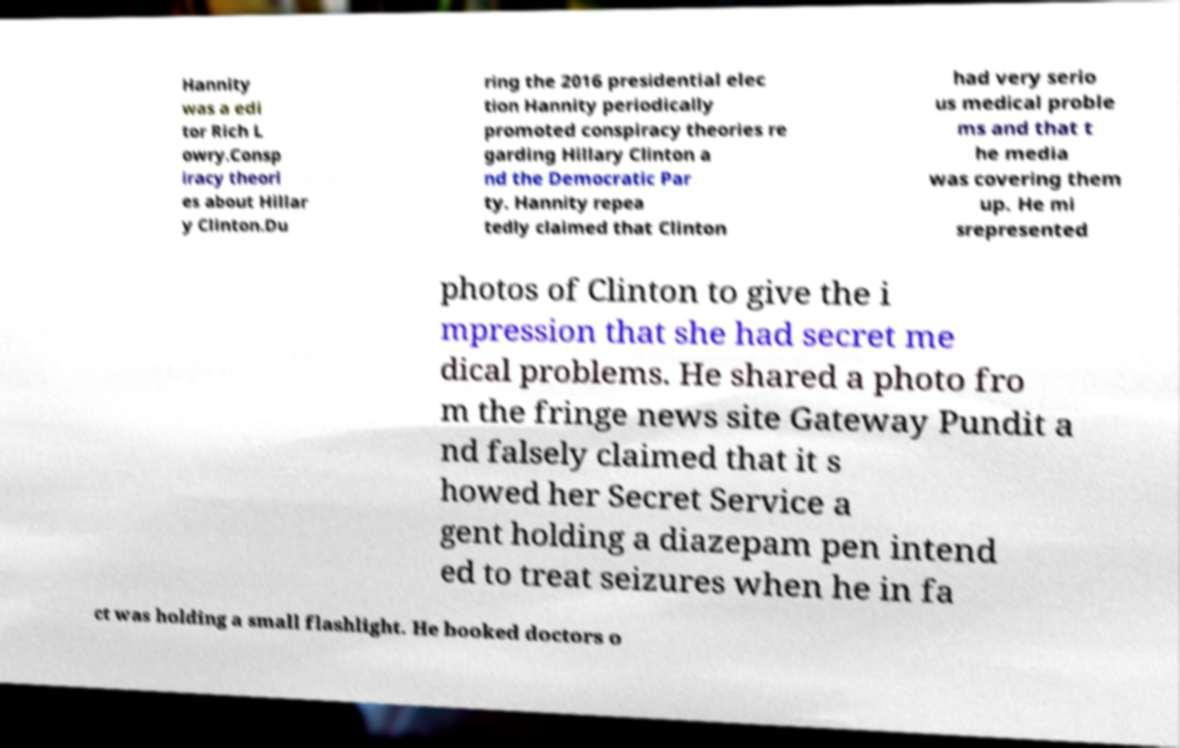What messages or text are displayed in this image? I need them in a readable, typed format. Hannity was a edi tor Rich L owry.Consp iracy theori es about Hillar y Clinton.Du ring the 2016 presidential elec tion Hannity periodically promoted conspiracy theories re garding Hillary Clinton a nd the Democratic Par ty. Hannity repea tedly claimed that Clinton had very serio us medical proble ms and that t he media was covering them up. He mi srepresented photos of Clinton to give the i mpression that she had secret me dical problems. He shared a photo fro m the fringe news site Gateway Pundit a nd falsely claimed that it s howed her Secret Service a gent holding a diazepam pen intend ed to treat seizures when he in fa ct was holding a small flashlight. He booked doctors o 